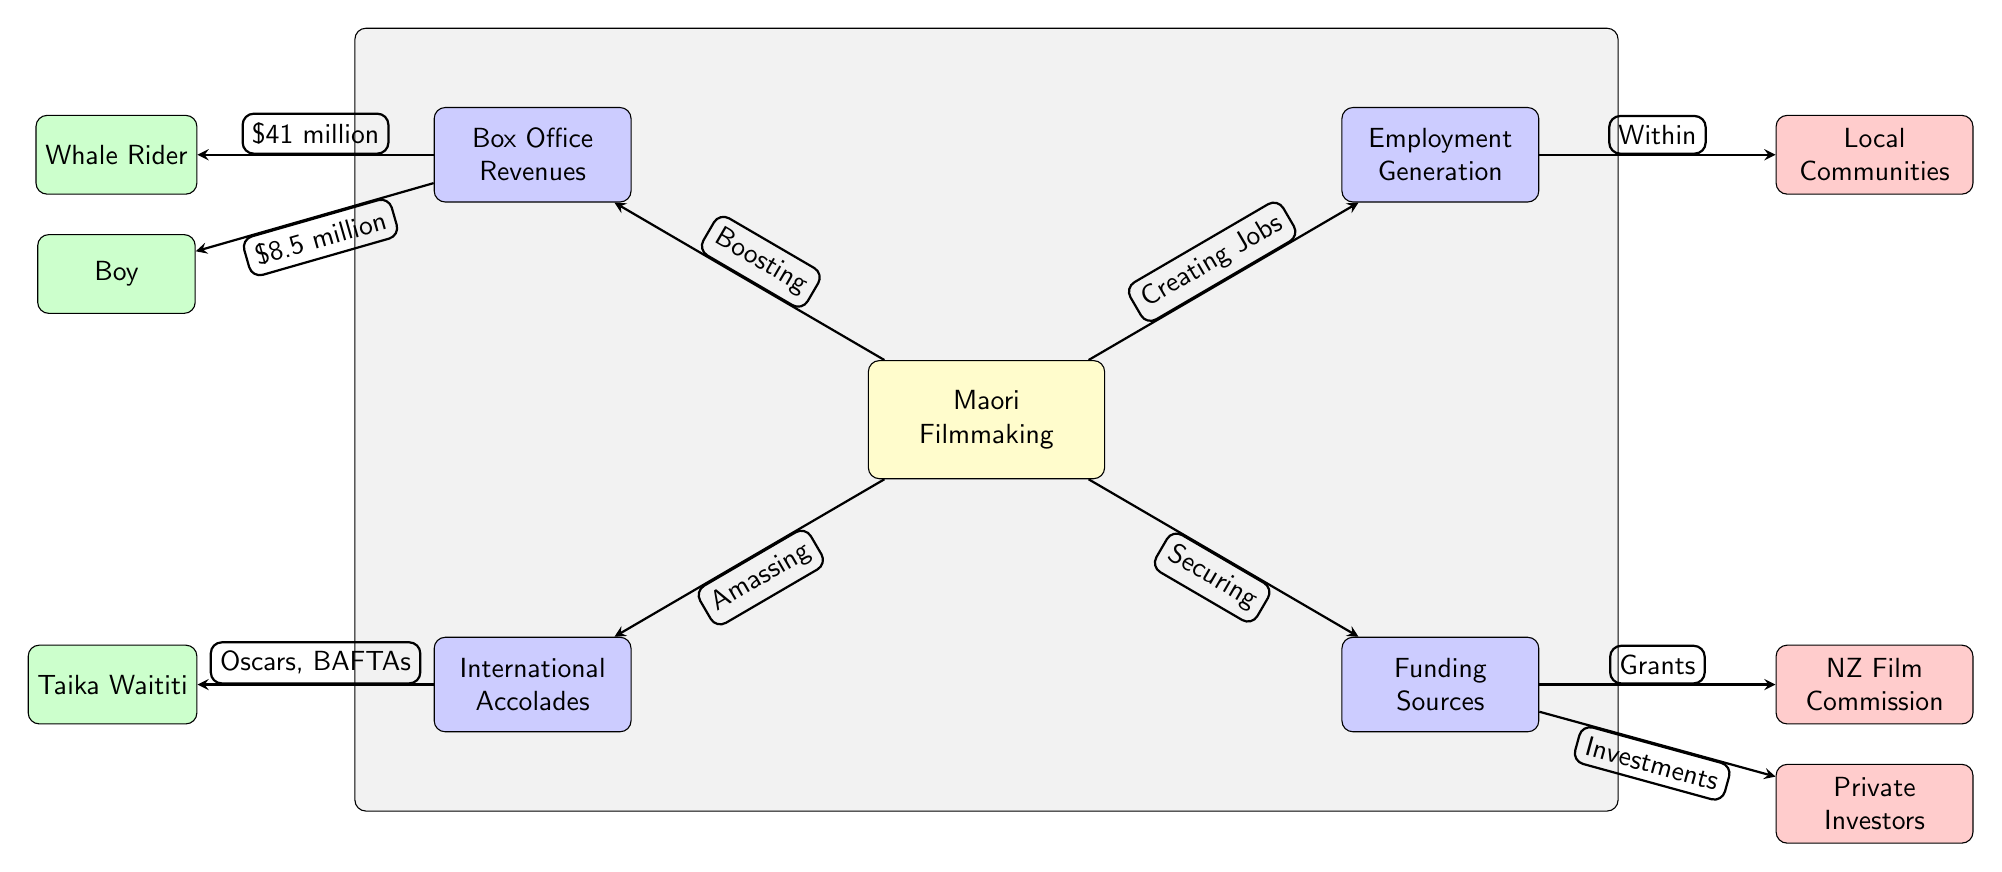What is the estimated box office revenue for "Whale Rider"? The node labeled "Whale Rider" under the "Box Office Revenues" section indicates a figure of $41 million. Hence, the answer comes directly from that connection.
Answer: $41 million What economic contribution does Māori filmmaking make to employment? The "Employment Generation" section connects "Creating Jobs" to the main topic of Māori filmmaking, signifying that it generates employment.
Answer: Creating Jobs What are the two types of funding sources identified in the diagram? The "Funding Sources" section lists both "NZ Film Commission" and "Private Investors," indicating these two as distinct funding sources for Māori filmmakers.
Answer: NZ Film Commission and Private Investors How many international awards are mentioned, and which ones? The "International Accolades" section points to "Oscars" and "BAFTAs," meaning a total of two awards are mentioned in the diagram.
Answer: Oscars and BAFTAs Which film is associated with a box office revenue of $8.5 million? The node labeled "Boy," located under the "Box Office Revenues," clearly indicates box office earnings of $8.5 million.
Answer: $8.5 million What primary impact does Māori filmmaking have on local communities? The diagram highlights "Within Local Communities," signaling that Māori filmmaking positively impacts these local entities by creating jobs and providing economic benefits.
Answer: Creating jobs Which filmmaker is connected to international accolades? The name "Taika Waititi" is mentioned in the "International Accolades" section of the diagram, indicating his connection to the noted awards.
Answer: Taika Waititi What color represents example nodes in the diagram? The "example" nodes, including "Whale Rider," "Boy," and "Taika Waititi," are filled with a green color according to the specified styles in the diagram.
Answer: Green What relationship is established between Māori filmmaking and box office revenues? The line labeled "Boosting" indicates that Māori filmmaking contributes positively to box office revenues, establishing a direct relationship.
Answer: Boosting 